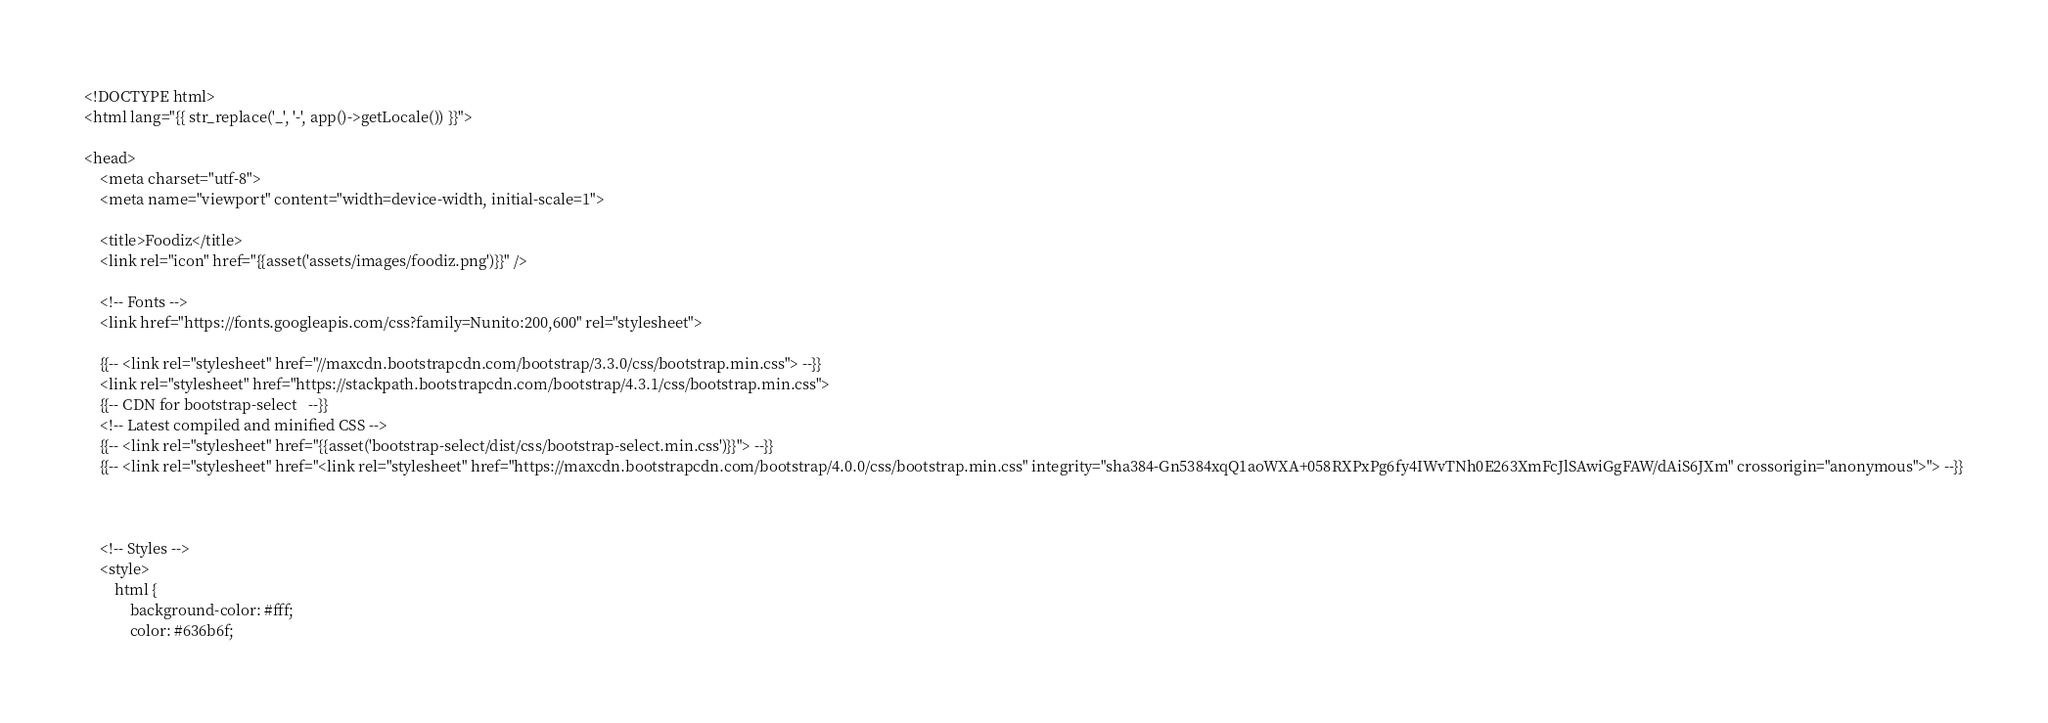<code> <loc_0><loc_0><loc_500><loc_500><_PHP_><!DOCTYPE html>
<html lang="{{ str_replace('_', '-', app()->getLocale()) }}">

<head>
    <meta charset="utf-8">
    <meta name="viewport" content="width=device-width, initial-scale=1">

    <title>Foodiz</title>
    <link rel="icon" href="{{asset('assets/images/foodiz.png')}}" />

    <!-- Fonts -->
    <link href="https://fonts.googleapis.com/css?family=Nunito:200,600" rel="stylesheet">

    {{-- <link rel="stylesheet" href="//maxcdn.bootstrapcdn.com/bootstrap/3.3.0/css/bootstrap.min.css"> --}}
    <link rel="stylesheet" href="https://stackpath.bootstrapcdn.com/bootstrap/4.3.1/css/bootstrap.min.css">
    {{-- CDN for bootstrap-select   --}}
    <!-- Latest compiled and minified CSS -->
    {{-- <link rel="stylesheet" href="{{asset('bootstrap-select/dist/css/bootstrap-select.min.css')}}"> --}}
    {{-- <link rel="stylesheet" href="<link rel="stylesheet" href="https://maxcdn.bootstrapcdn.com/bootstrap/4.0.0/css/bootstrap.min.css" integrity="sha384-Gn5384xqQ1aoWXA+058RXPxPg6fy4IWvTNh0E263XmFcJlSAwiGgFAW/dAiS6JXm" crossorigin="anonymous">"> --}}



    <!-- Styles -->
    <style>
        html {
            background-color: #fff;
            color: #636b6f;</code> 